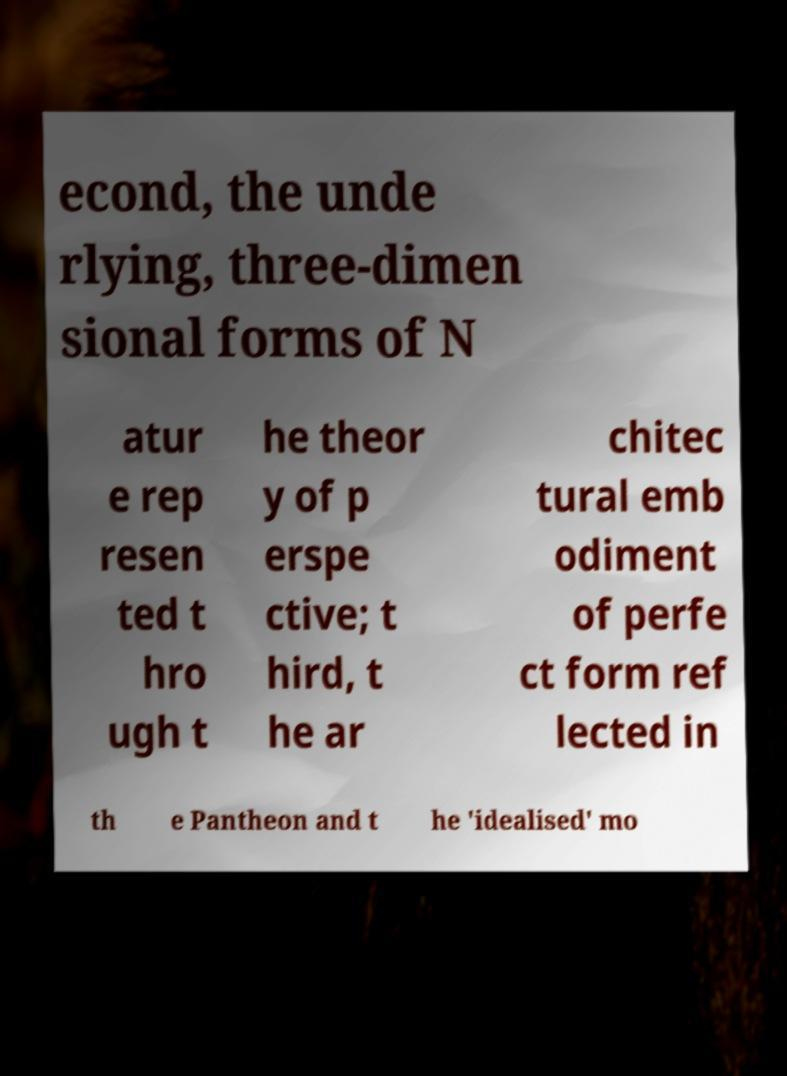Could you extract and type out the text from this image? econd, the unde rlying, three-dimen sional forms of N atur e rep resen ted t hro ugh t he theor y of p erspe ctive; t hird, t he ar chitec tural emb odiment of perfe ct form ref lected in th e Pantheon and t he 'idealised' mo 